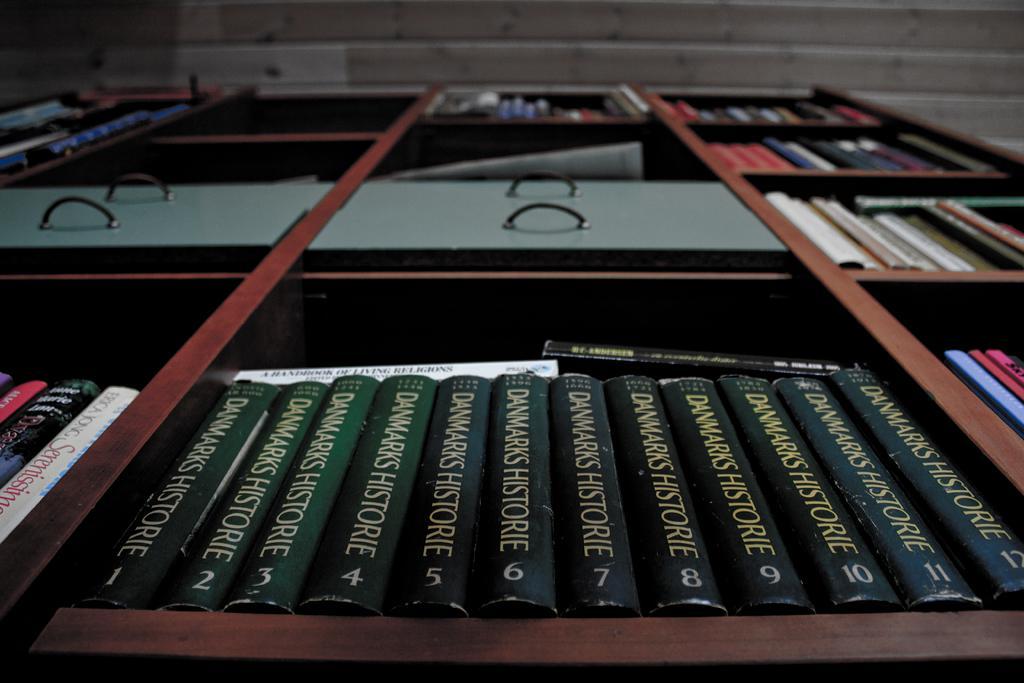Provide a one-sentence caption for the provided image. Twelve volumes of Dwarks Historie line a bookshelf, their green spines all alike. 